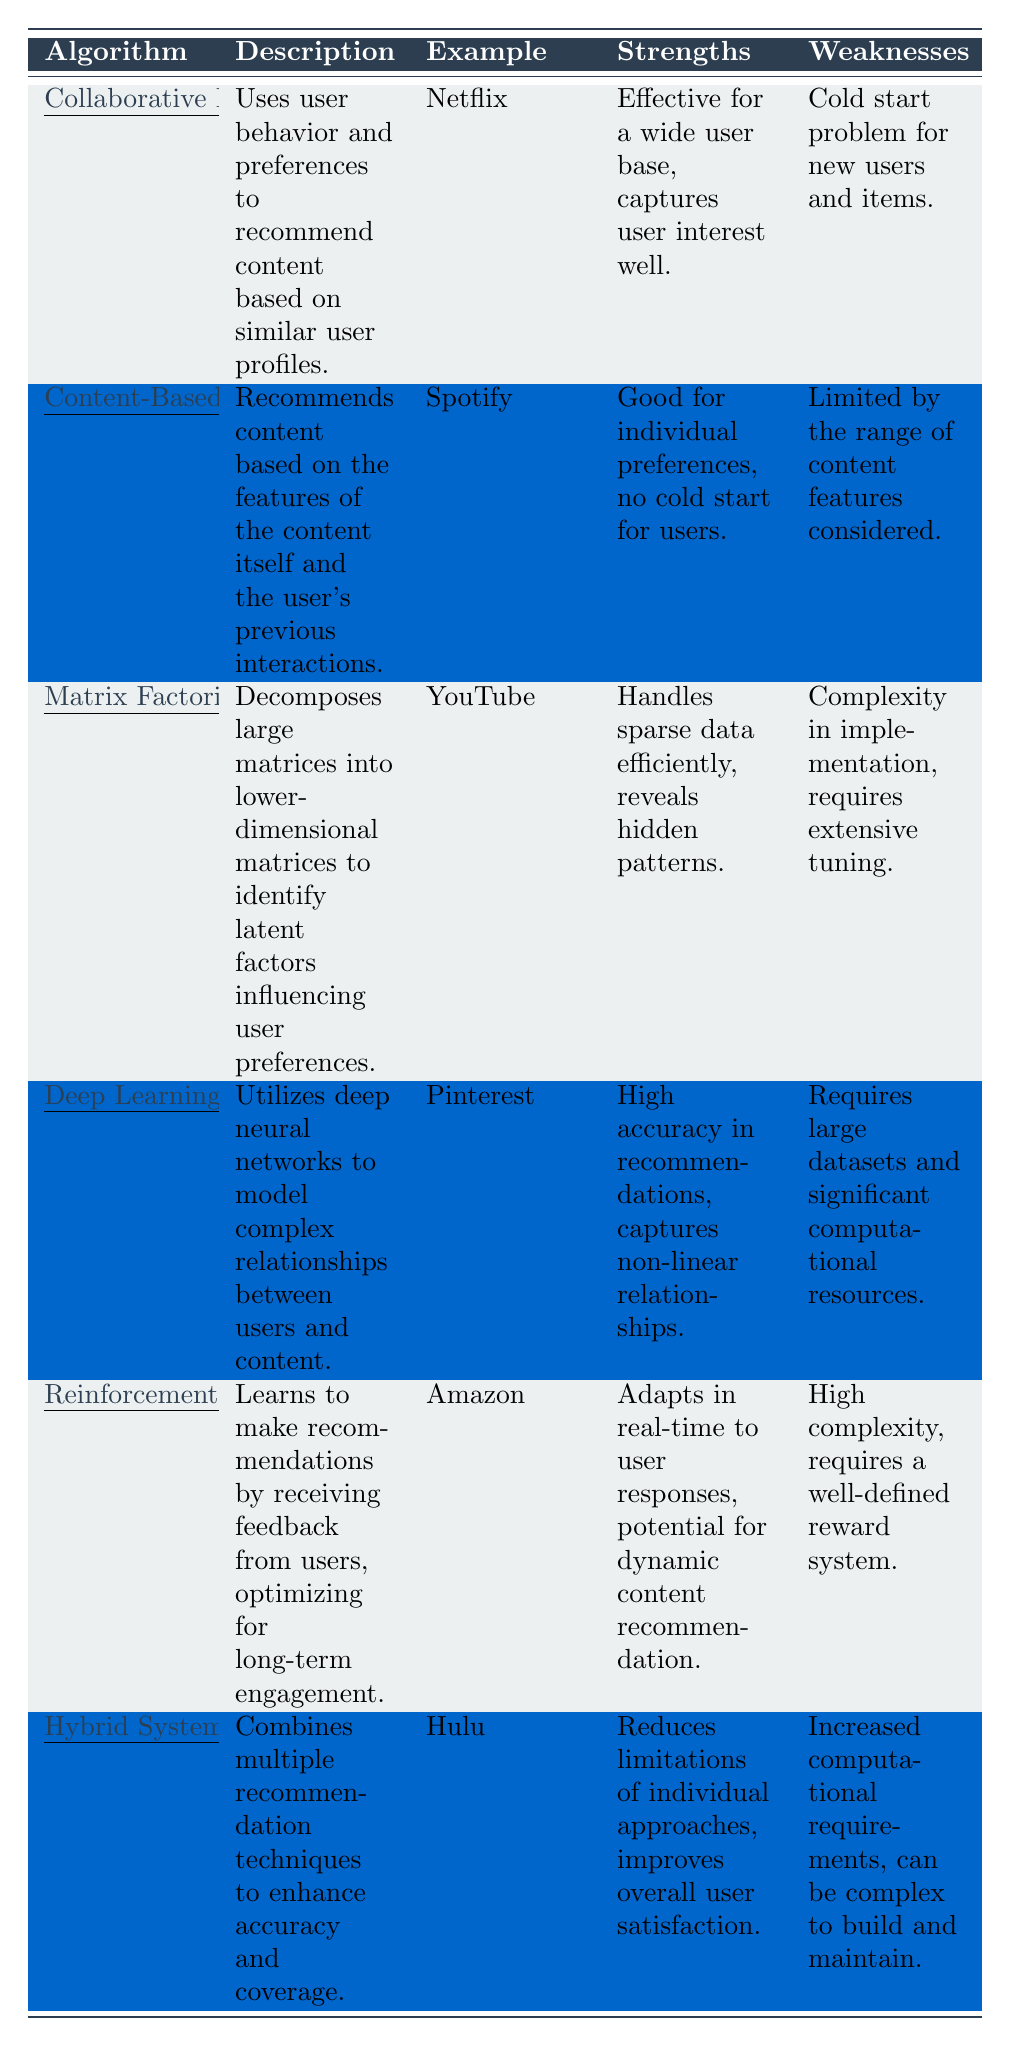What is the algorithm used by Netflix for content recommendation? According to the table, Netflix uses Collaborative Filtering as its recommendation algorithm.
Answer: Collaborative Filtering Which algorithm is effective for individual preferences and has no cold start for users? The algorithm that is effective for individual preferences and has no cold start for users according to the table is Content-Based Filtering.
Answer: Content-Based Filtering What are the strengths of Matrix Factorization? The strengths of Matrix Factorization listed in the table include handling sparse data efficiently and revealing hidden patterns.
Answer: Handling sparse data efficiently, revealing hidden patterns Is Deep Learning recommended for small datasets? The table states that Deep Learning requires large datasets and significant computational resources, indicating it is not recommended for small datasets.
Answer: No Which two algorithms have "complexity" listed as a weakness? The table indicates that both Matrix Factorization and Reinforcement Learning have "complexity" mentioned as a weakness.
Answer: Matrix Factorization, Reinforcement Learning What is the description of Hybrid Systems? The description for Hybrid Systems provided in the table states that it combines multiple recommendation techniques to enhance accuracy and coverage.
Answer: Combines multiple recommendation techniques to enhance accuracy and coverage Which algorithm is specifically noted for its use in Amazon's recommendation system? According to the table, Reinforcement Learning is the algorithm specifically noted for use in Amazon's recommendation system.
Answer: Reinforcement Learning What is the main weakness of Collaborative Filtering? The main weakness of Collaborative Filtering, as indicated in the table, is the cold start problem for new users and items.
Answer: Cold start problem for new users and items If all algorithms listed have strengths and weaknesses, which one has the strength of high accuracy in recommendations? The table states that Deep Learning (Neural Networks) has the strength of high accuracy in recommendations.
Answer: Deep Learning (Neural Networks) What could be a downside when building Hybrid Systems? The table notes that a downside when building Hybrid Systems can be increased computational requirements and complexity.
Answer: Increased computational requirements, complexity Which algorithm revealed hidden patterns effectively? The table specifies that Matrix Factorization is the algorithm that reveals hidden patterns effectively.
Answer: Matrix Factorization 